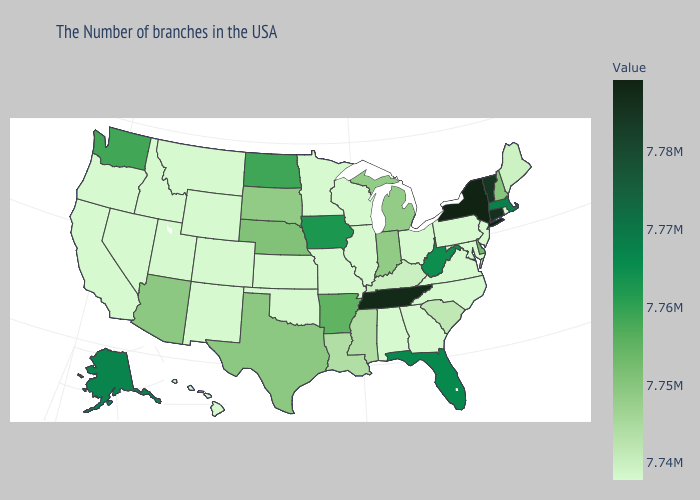Among the states that border South Carolina , which have the lowest value?
Short answer required. North Carolina, Georgia. Does New Hampshire have the lowest value in the Northeast?
Keep it brief. No. Does the map have missing data?
Answer briefly. No. Is the legend a continuous bar?
Be succinct. Yes. Which states have the highest value in the USA?
Short answer required. New York. Which states have the lowest value in the USA?
Keep it brief. Rhode Island, New Jersey, Maryland, Pennsylvania, Virginia, North Carolina, Ohio, Georgia, Alabama, Wisconsin, Illinois, Missouri, Minnesota, Kansas, Oklahoma, Wyoming, Colorado, New Mexico, Utah, Montana, Idaho, Nevada, California, Oregon, Hawaii. 